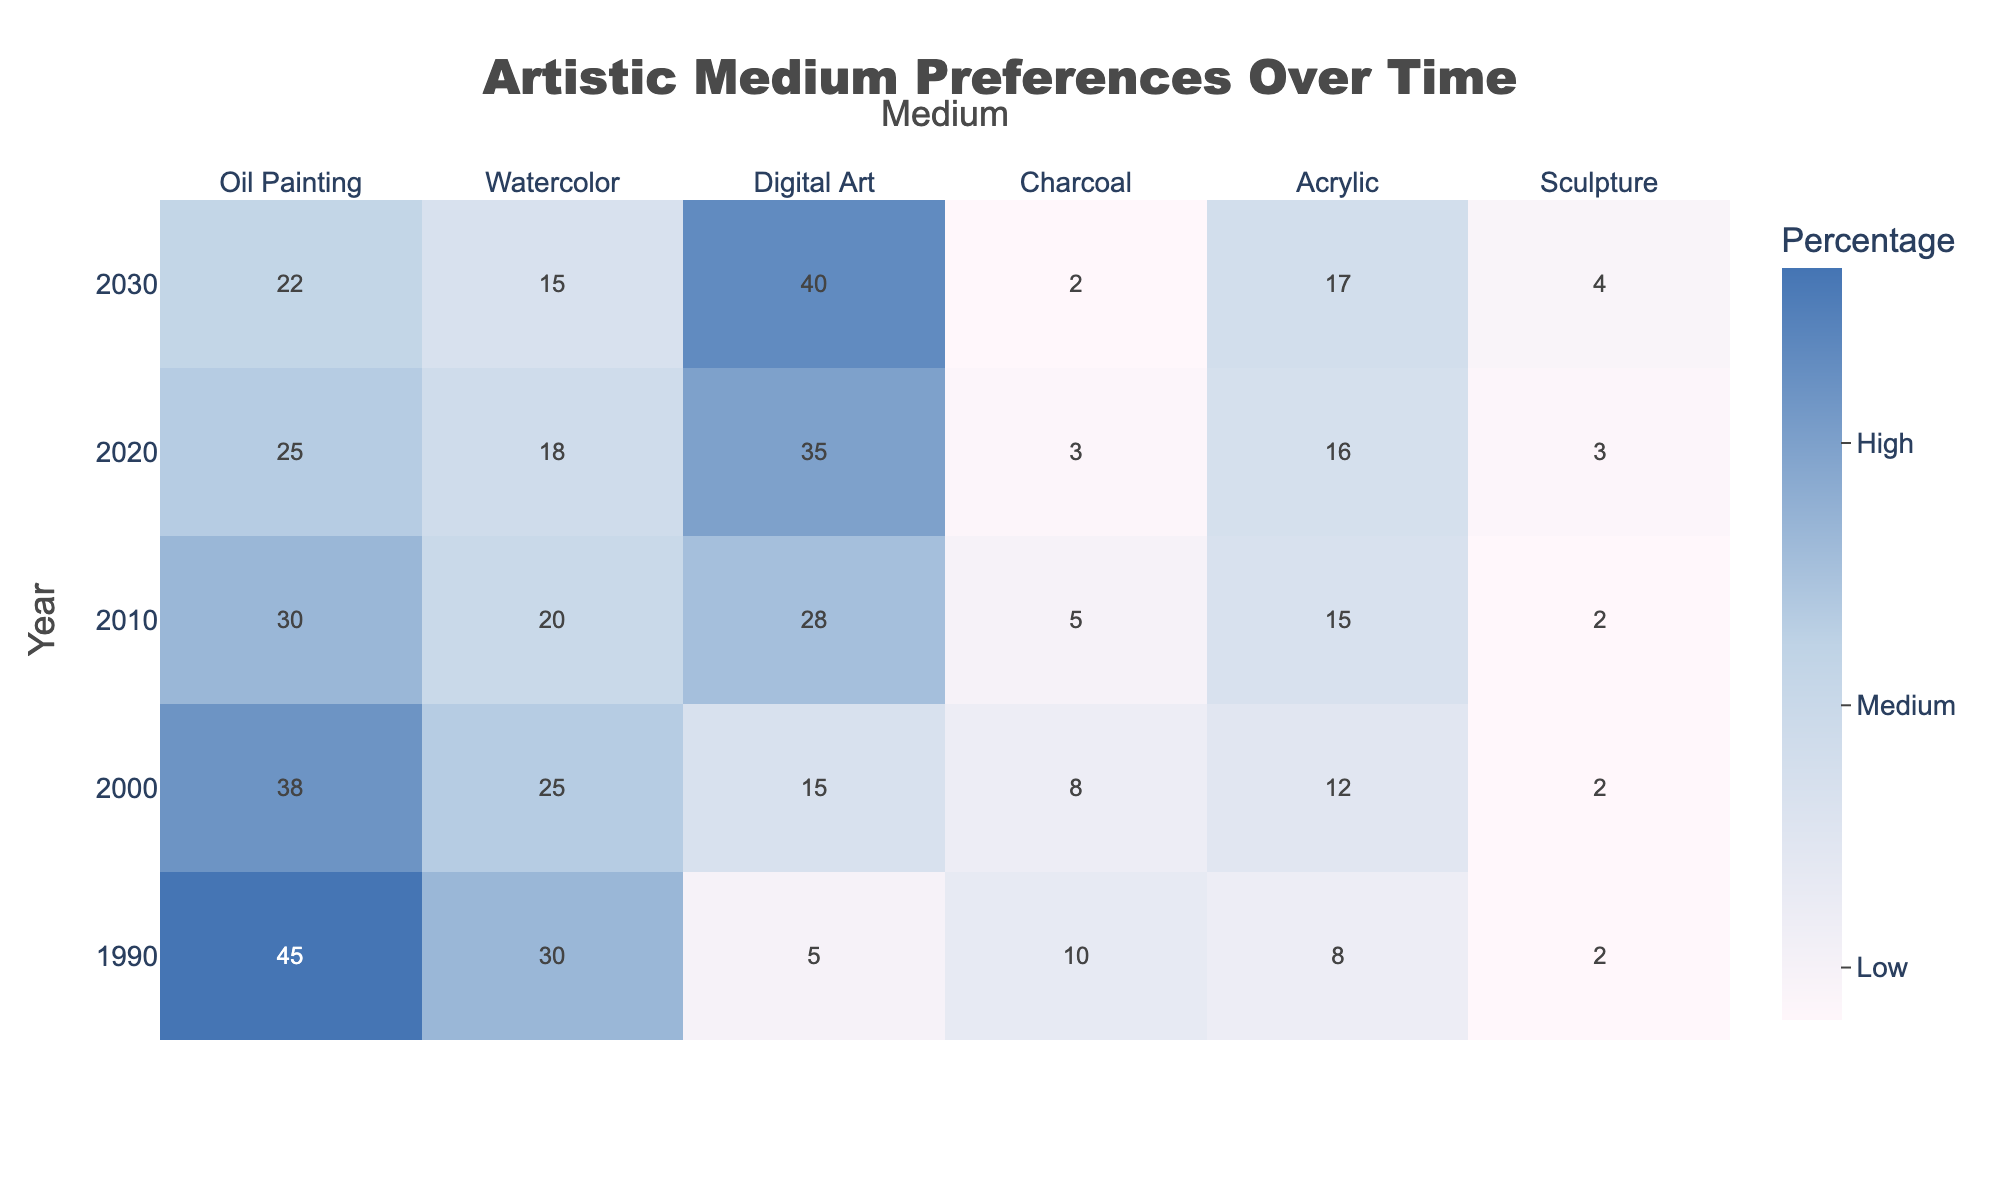What was the percentage of Oil Painting preference in 2010? In the table, we can find the value for Oil Painting in the year 2010, which is listed as 30.
Answer: 30 Which artistic medium had the highest preference in 2020? Looking at the table for the year 2020, Digital Art has the highest value of 35 compared to other mediums.
Answer: Digital Art What is the difference in preference for Sculpture between 1990 and 2020? We check the value for Sculpture in 1990, which is 2, and in 2020, it is 3. The difference is calculated as 3 - 2 = 1.
Answer: 1 What was the percentage of preference for Charcoal in 2030? The percentage for Charcoal in 2030, as stated in the table, is 2.
Answer: 2 What was the average preference for Watercolor from 1990 to 2030? We sum the preferences of Watercolor: 30 (1990) + 25 (2000) + 20 (2010) + 18 (2020) + 15 (2030) = 108. Since there are 5 years, we calculate the average as 108 / 5 = 21.6.
Answer: 21.6 Is the percentage of Acrylic preference increasing over the years? The values for Acrylic are: 8 (1990), 12 (2000), 15 (2010), 16 (2020), and 17 (2030). Since each value is increasing, the trend is confirmed to be increasing.
Answer: Yes Which artistic medium had the steepest decline in preference from 1990 to 2020? For each medium, we calculate the decline: Oil Painting: 45 - 25 = 20; Watercolor: 30 - 18 = 12; Digital Art: 5 - 35 = -30; Charcoal: 10 - 3 = 7; Acrylic: 8 - 16 = -8; Sculpture: 2 - 3 = -1. Oil Painting had the largest decline of 20.
Answer: Oil Painting What was the total preference for all mediums in 2000? We sum all the values for the year 2000: 38 (Oil Painting) + 25 (Watercolor) + 15 (Digital Art) + 8 (Charcoal) + 12 (Acrylic) + 2 (Sculpture) = 100.
Answer: 100 What are the two mediums with the lowest percentage in 1990? In 1990, Sculpture has the lowest at 2 and Digital Art has 5. Thus, the two lowest are Sculpture and Digital Art.
Answer: Sculpture and Digital Art Was the percentage of preference for Digital Art more than that for Charcoal in 2030? The values in 2030 are 40 for Digital Art and 2 for Charcoal. Since 40 is greater than 2, the statement is true.
Answer: Yes 